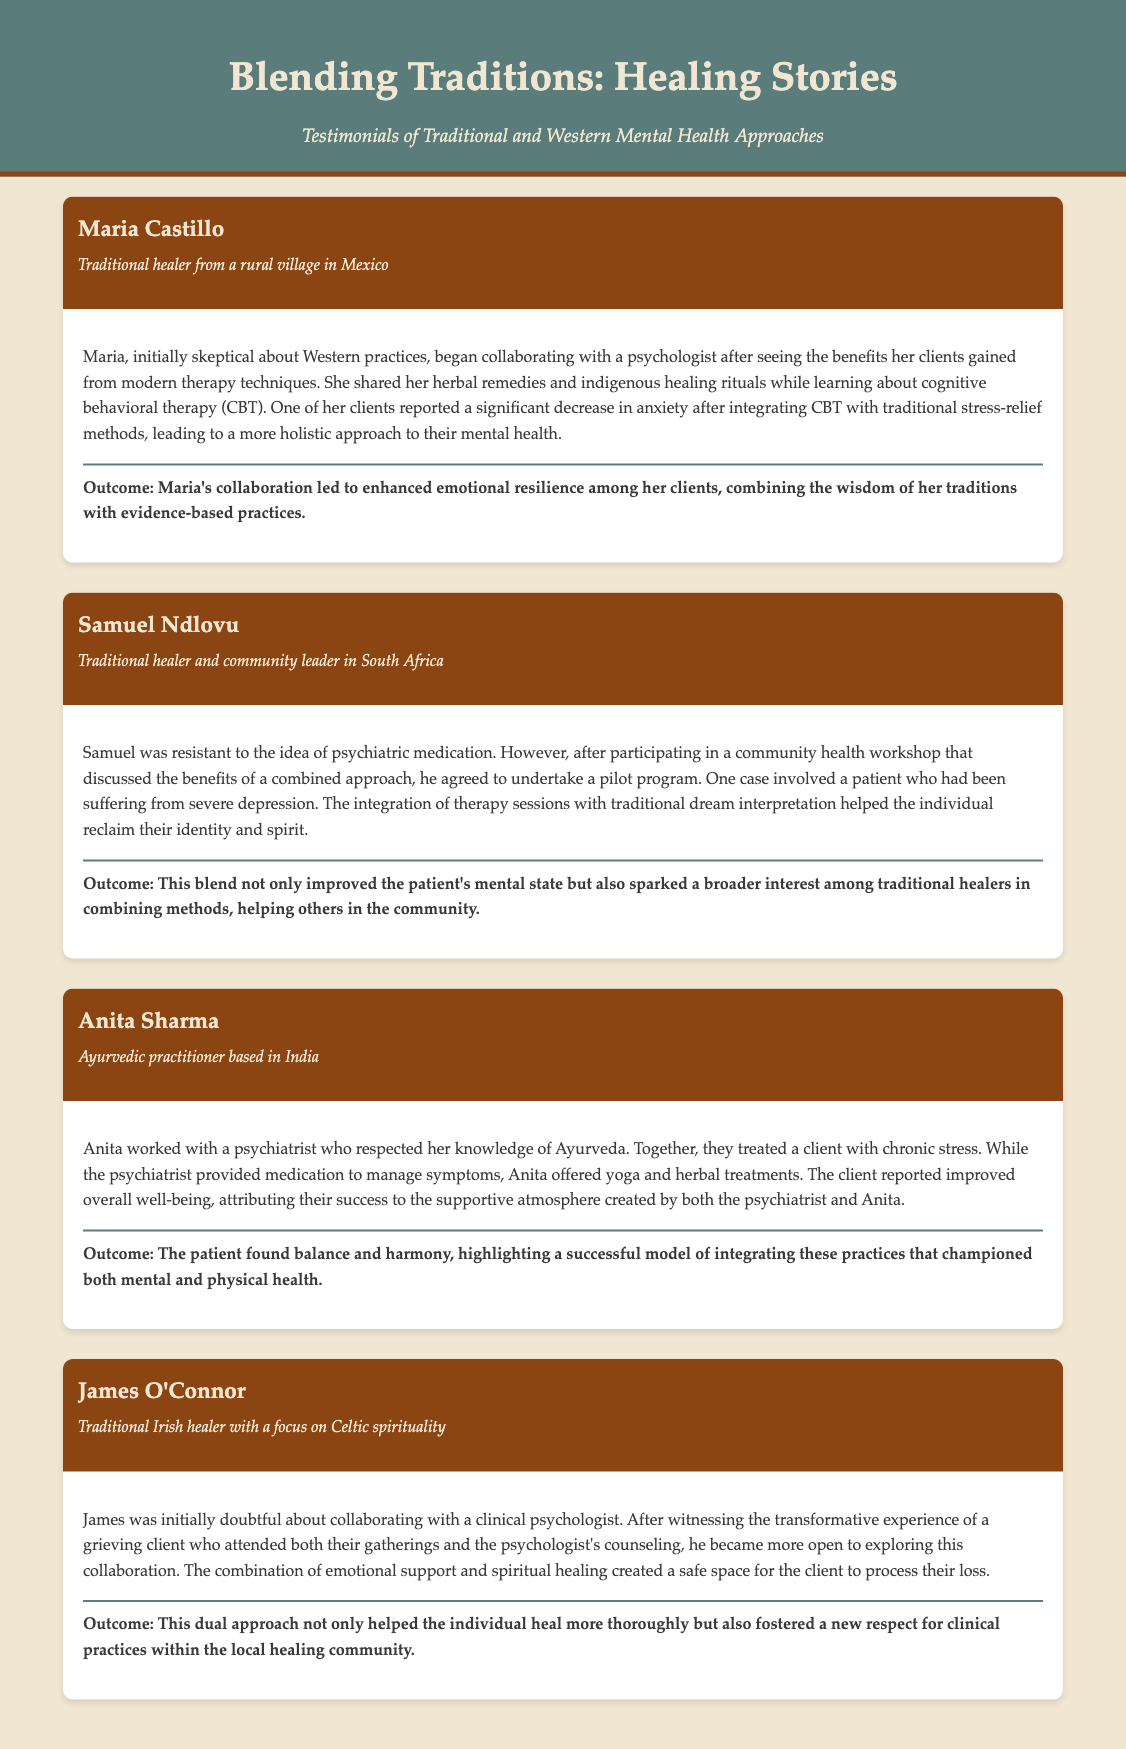What is the name of the first testimonial? The first testimonial is from Maria Castillo.
Answer: Maria Castillo Which country is Samuel Ndlovu from? Samuel Ndlovu is from South Africa.
Answer: South Africa What alternative healing practice does Anita Sharma specialize in? Anita Sharma specializes in Ayurveda.
Answer: Ayurveda What method did the psychiatrist provide to manage symptoms for Anita's client? The psychiatrist provided medication to manage symptoms.
Answer: Medication What was James O'Connor's focus in his healing practice? James O'Connor's focus is on Celtic spirituality.
Answer: Celtic spirituality What outcome did Maria report after integrating CBT with traditional methods? Maria reported enhanced emotional resilience among her clients.
Answer: Enhanced emotional resilience How did the community respond to Samuel's pilot program? The community showed broader interest among traditional healers in combining methods.
Answer: Broader interest What holistic practice was combined with Western therapy in Anita's case? Yoga and herbal treatments were combined with Western therapy.
Answer: Yoga and herbal treatments Who inspired James O'Connor to be more open to collaboration? A grieving client who attended both their gatherings and the psychologist's counseling inspired James.
Answer: A grieving client 